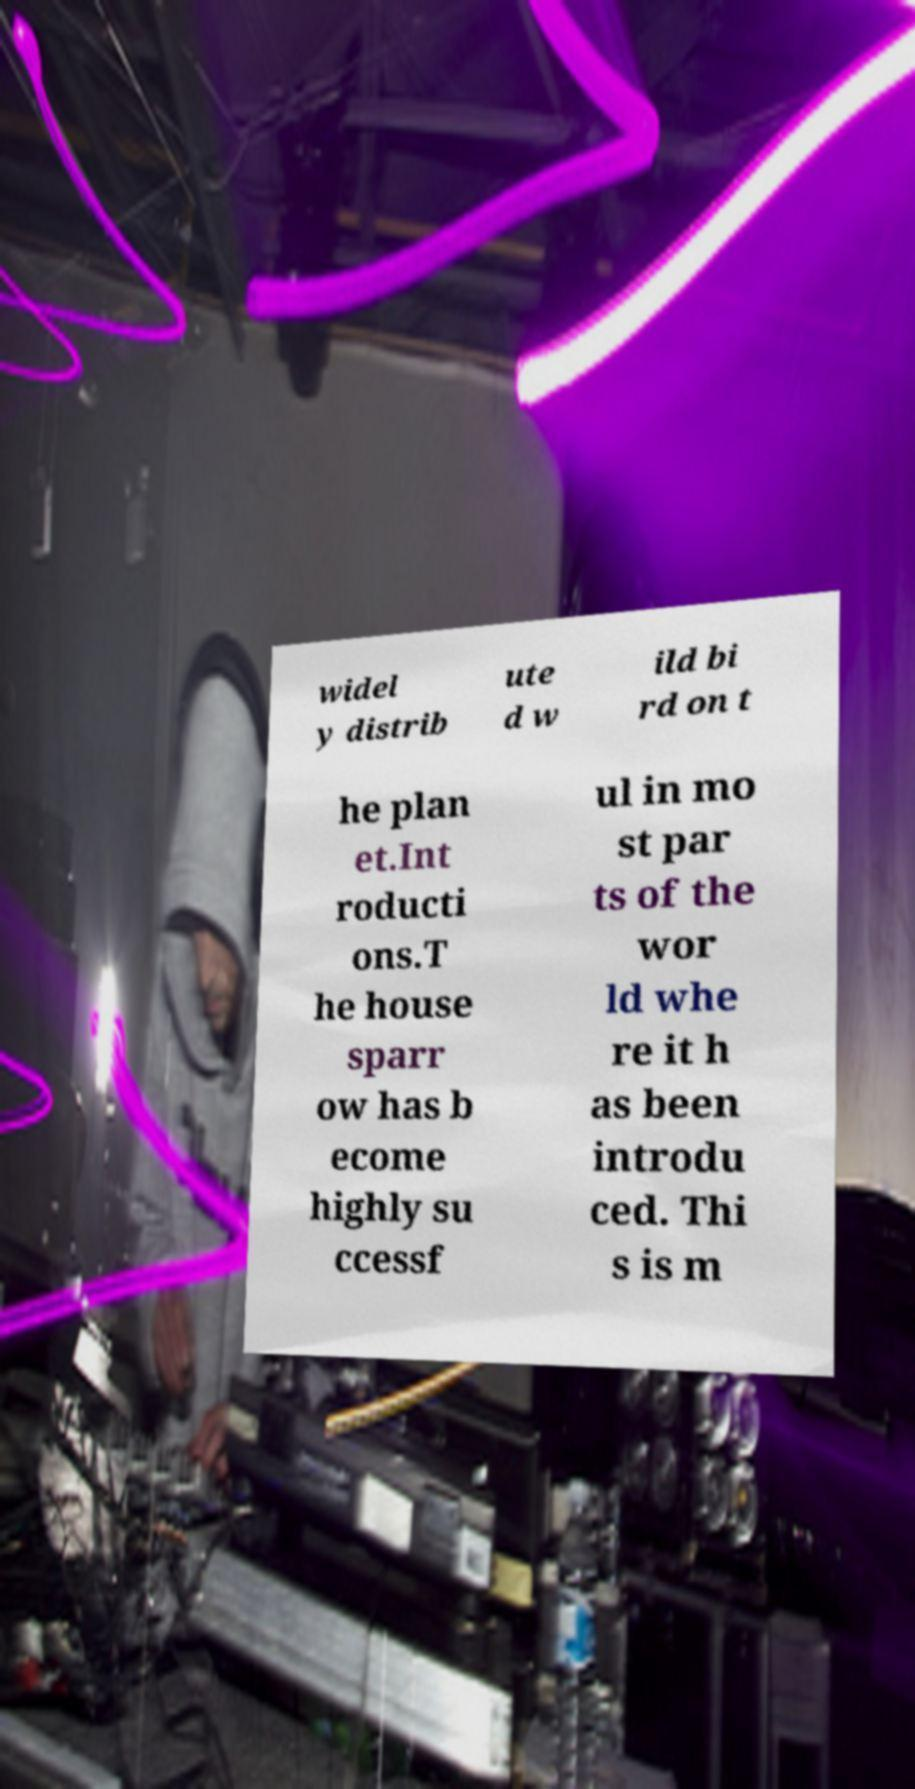There's text embedded in this image that I need extracted. Can you transcribe it verbatim? widel y distrib ute d w ild bi rd on t he plan et.Int roducti ons.T he house sparr ow has b ecome highly su ccessf ul in mo st par ts of the wor ld whe re it h as been introdu ced. Thi s is m 